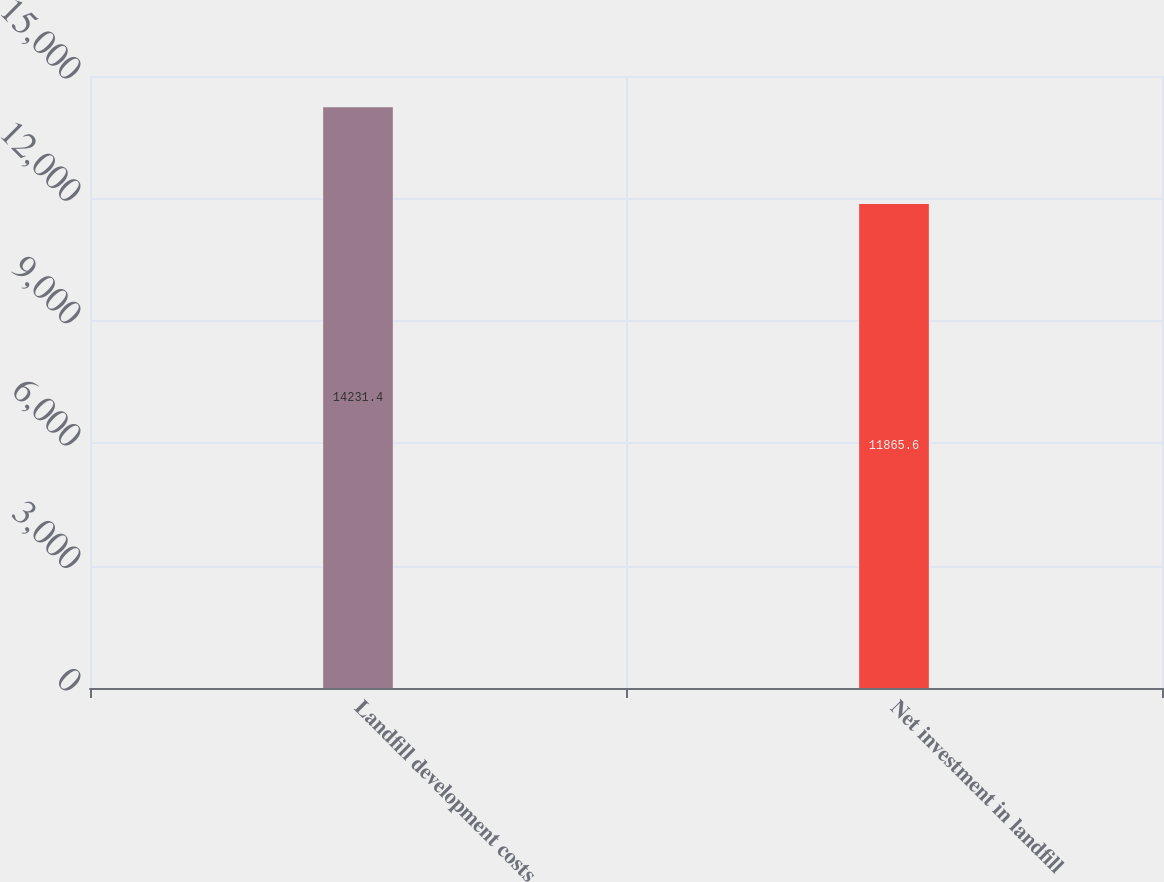<chart> <loc_0><loc_0><loc_500><loc_500><bar_chart><fcel>Landfill development costs<fcel>Net investment in landfill<nl><fcel>14231.4<fcel>11865.6<nl></chart> 